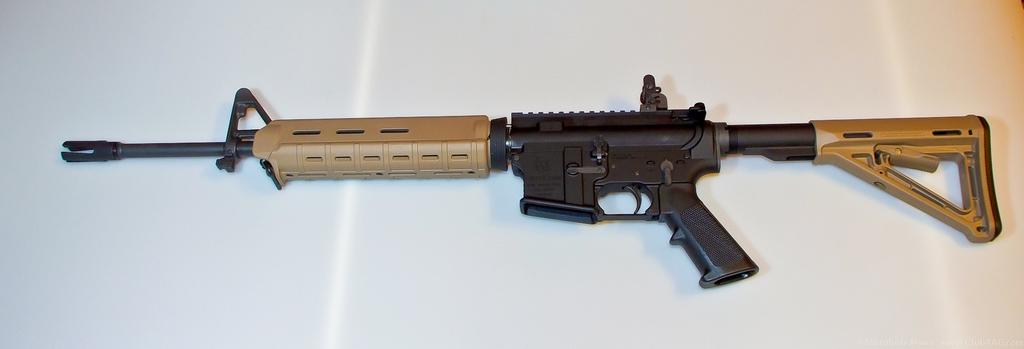What type of object is present in the image? There is a weapon in the image. What nation is depicted on the crack in the image? There is no crack or nation present in the image; it only features a weapon. How many quivers are visible in the image? There is no quiver present in the image; only a weapon is visible. 